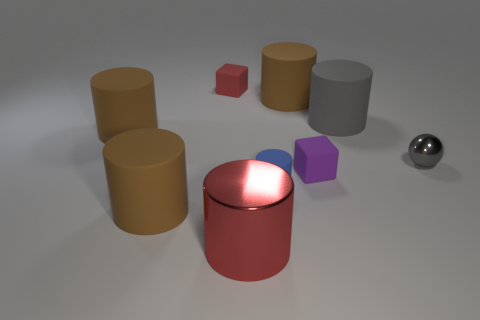How many brown cylinders must be subtracted to get 2 brown cylinders? 1 Subtract all gray balls. How many brown cylinders are left? 3 Subtract all shiny cylinders. How many cylinders are left? 5 Subtract all blue cylinders. How many cylinders are left? 5 Subtract all gray cylinders. Subtract all blue balls. How many cylinders are left? 5 Add 1 large gray things. How many objects exist? 10 Subtract all spheres. How many objects are left? 8 Add 7 gray rubber cylinders. How many gray rubber cylinders exist? 8 Subtract 1 red cylinders. How many objects are left? 8 Subtract all red cylinders. Subtract all large shiny things. How many objects are left? 7 